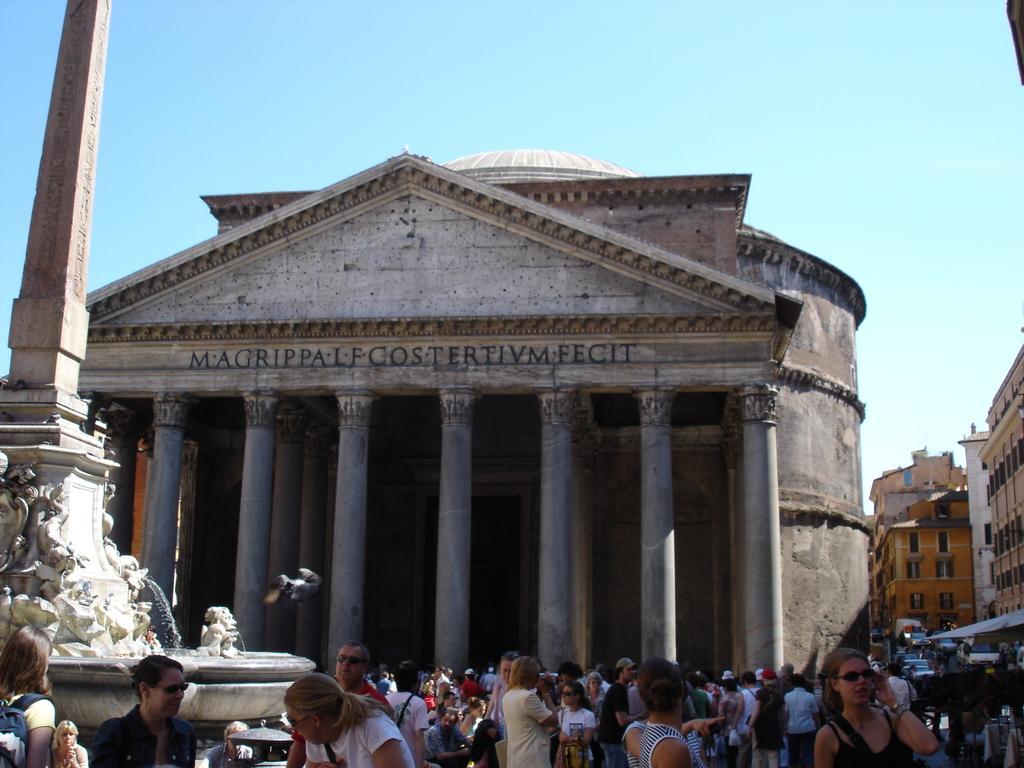How would you summarize this image in a sentence or two? Buildings with pillars and windows. Sky is in blue color. Here we can see crowd. 